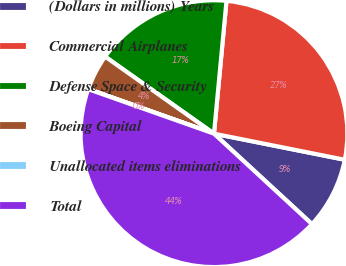Convert chart to OTSL. <chart><loc_0><loc_0><loc_500><loc_500><pie_chart><fcel>(Dollars in millions) Years<fcel>Commercial Airplanes<fcel>Defense Space & Security<fcel>Boeing Capital<fcel>Unallocated items eliminations<fcel>Total<nl><fcel>8.73%<fcel>26.64%<fcel>16.69%<fcel>4.37%<fcel>0.02%<fcel>43.55%<nl></chart> 